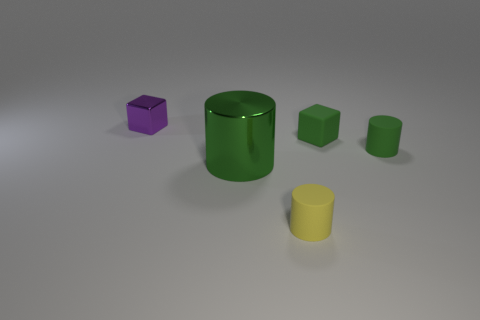What color is the small cylinder right of the cube in front of the small purple metallic object?
Your answer should be very brief. Green. What material is the big green object that is the same shape as the tiny yellow thing?
Make the answer very short. Metal. The matte thing in front of the rubber cylinder that is right of the small cylinder in front of the large green metallic cylinder is what color?
Ensure brevity in your answer.  Yellow. How many objects are tiny yellow matte objects or big cubes?
Give a very brief answer. 1. What number of tiny green matte things have the same shape as the yellow object?
Ensure brevity in your answer.  1. Is the material of the yellow thing the same as the small object behind the green cube?
Offer a very short reply. No. There is a green block that is made of the same material as the yellow cylinder; what is its size?
Offer a terse response. Small. How big is the green thing that is behind the small green cylinder?
Keep it short and to the point. Small. What number of other green rubber blocks are the same size as the green matte block?
Provide a short and direct response. 0. What size is the cylinder that is the same color as the large object?
Provide a short and direct response. Small. 